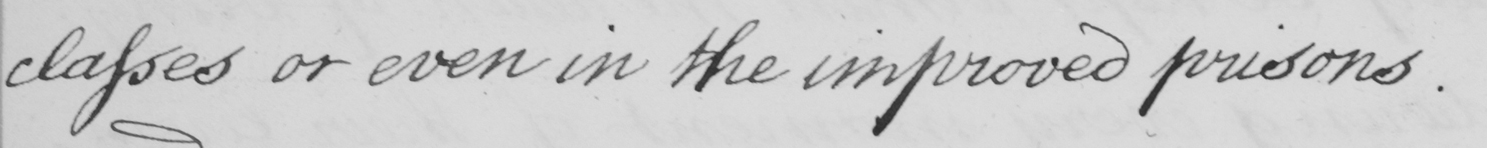Please transcribe the handwritten text in this image. classes or even in the improved prisons. 